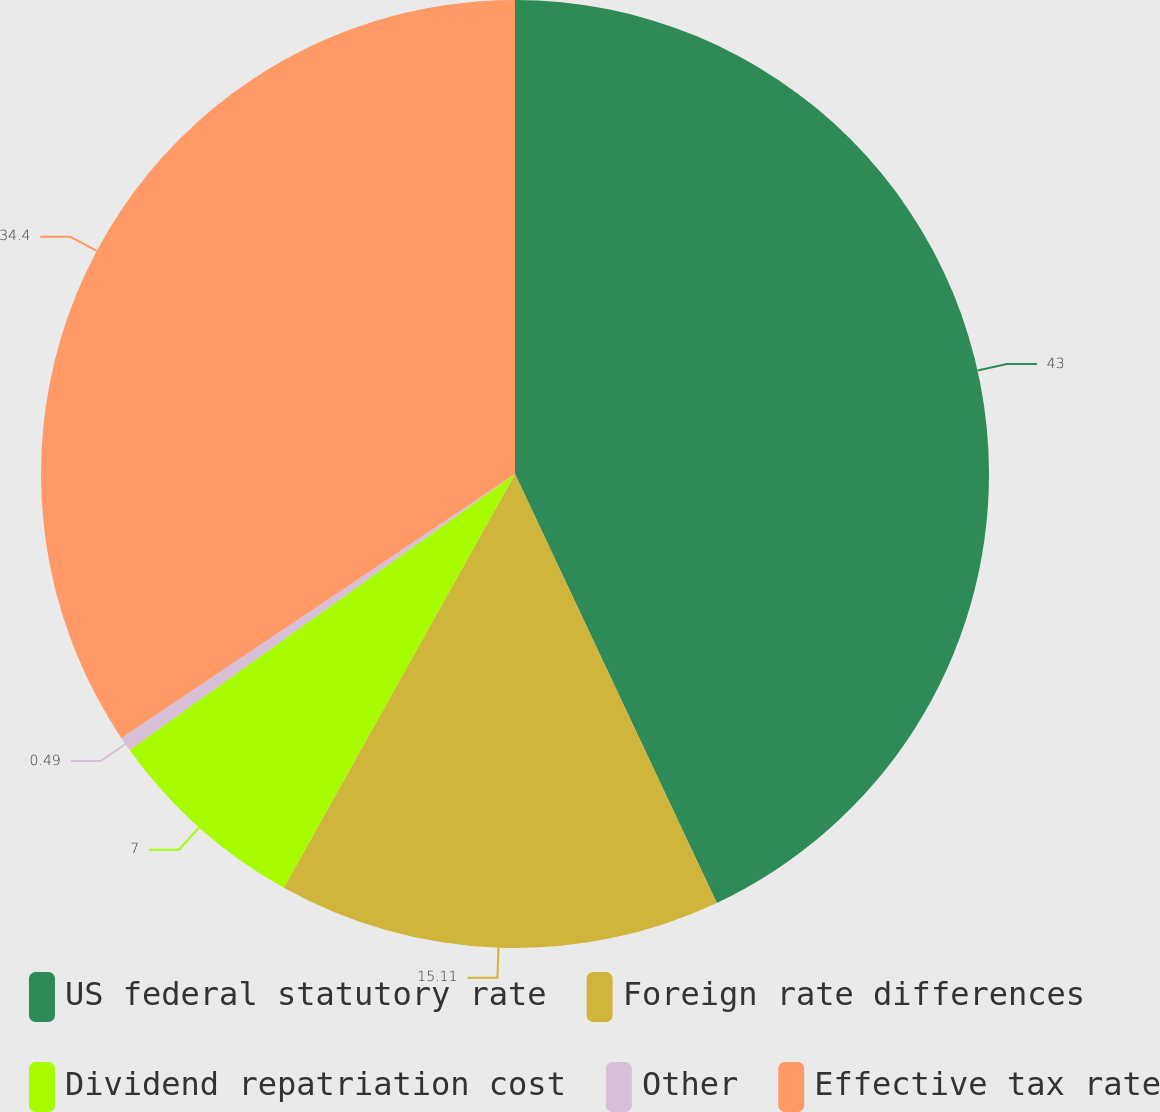<chart> <loc_0><loc_0><loc_500><loc_500><pie_chart><fcel>US federal statutory rate<fcel>Foreign rate differences<fcel>Dividend repatriation cost<fcel>Other<fcel>Effective tax rate<nl><fcel>43.0%<fcel>15.11%<fcel>7.0%<fcel>0.49%<fcel>34.4%<nl></chart> 